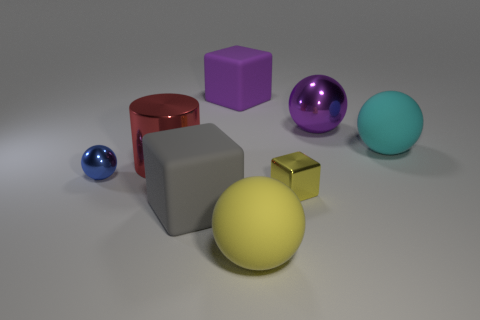Could you explain how the composition of this image might be aesthetically pleasing? Yes, the composition of the image is balanced and symmetrical in a way that is visually soothing. The placement of objects is neither too crowded nor too sparse, offering a harmonious distribution of forms across the field of view. The color palette is diverse but not jarring, with complementary colors such as the purple and yellow providing vivid contrasts that draw the eye. The smooth interplay of light and shadow adds depth and a sense of serenity to the scene. 